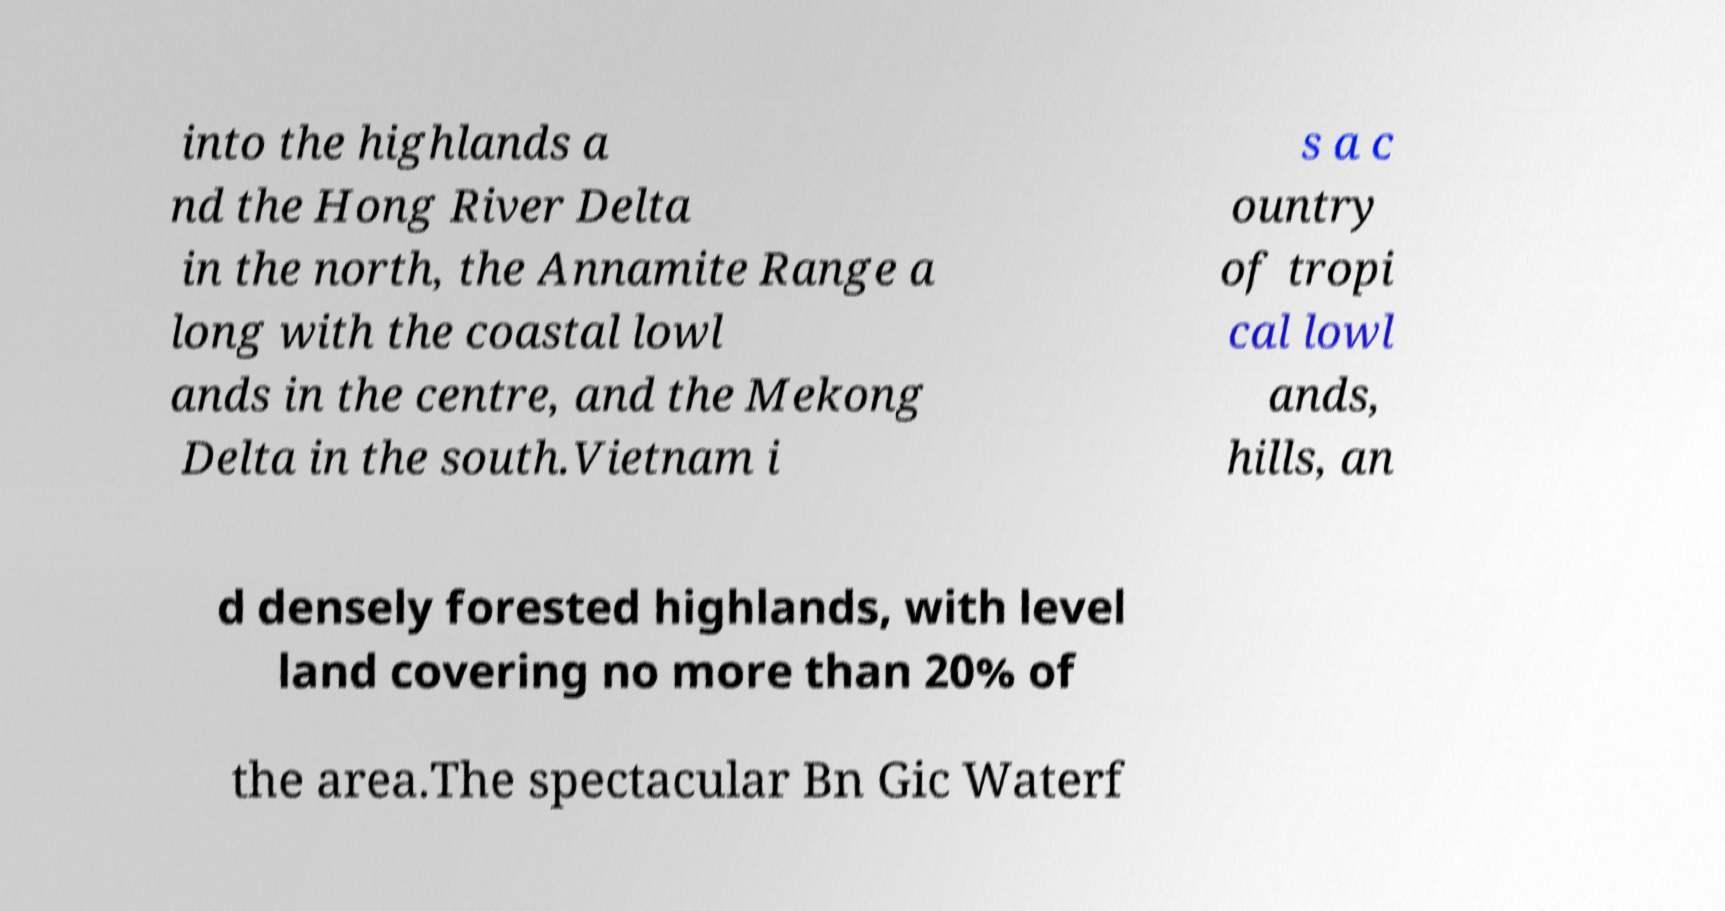Please identify and transcribe the text found in this image. into the highlands a nd the Hong River Delta in the north, the Annamite Range a long with the coastal lowl ands in the centre, and the Mekong Delta in the south.Vietnam i s a c ountry of tropi cal lowl ands, hills, an d densely forested highlands, with level land covering no more than 20% of the area.The spectacular Bn Gic Waterf 